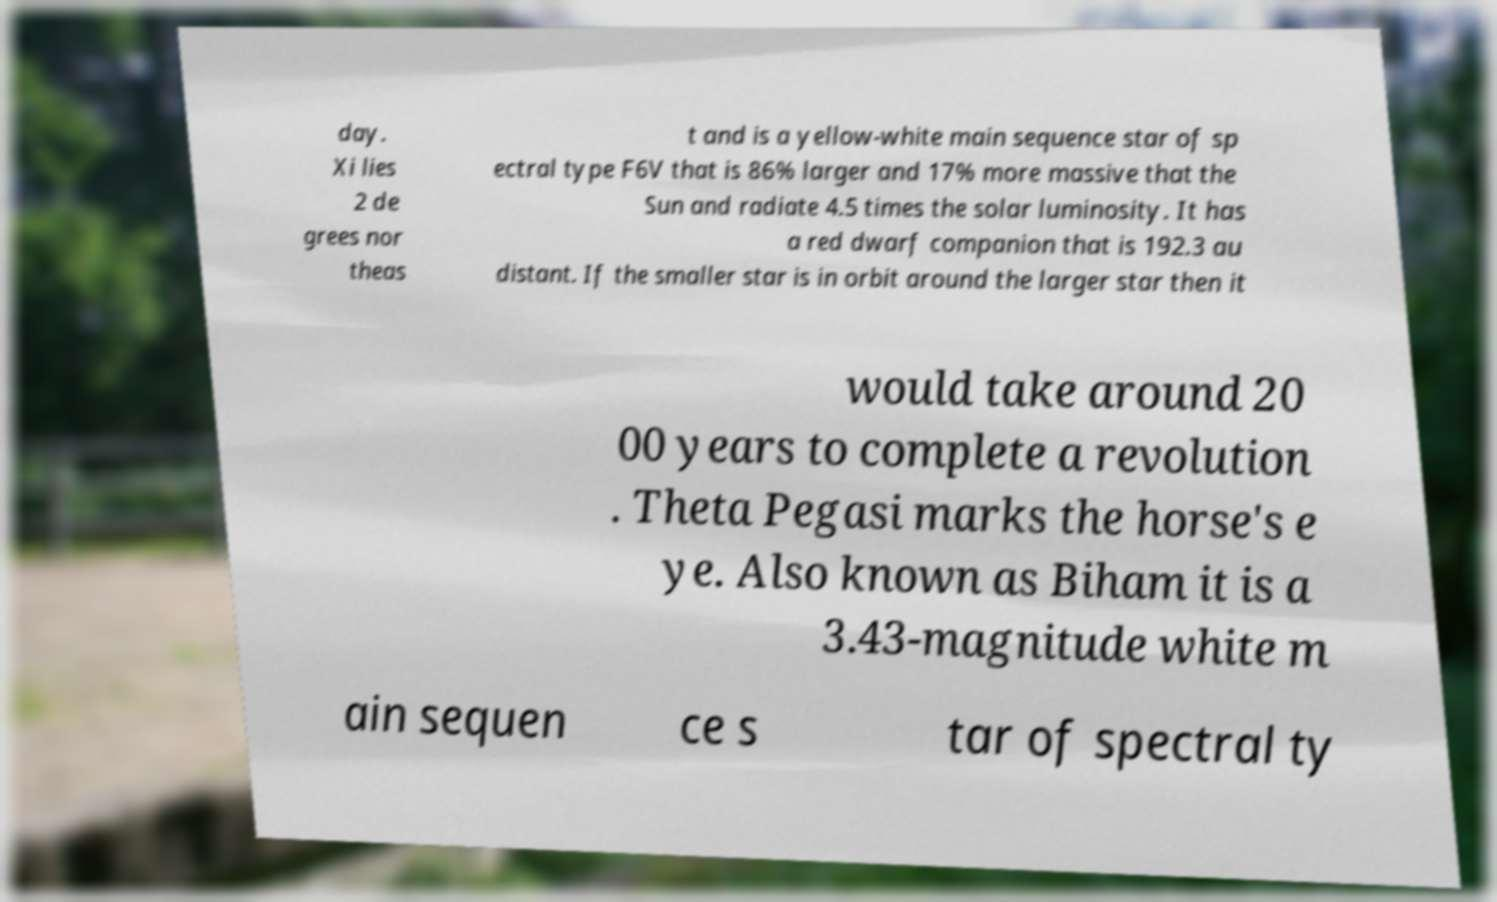Please identify and transcribe the text found in this image. day. Xi lies 2 de grees nor theas t and is a yellow-white main sequence star of sp ectral type F6V that is 86% larger and 17% more massive that the Sun and radiate 4.5 times the solar luminosity. It has a red dwarf companion that is 192.3 au distant. If the smaller star is in orbit around the larger star then it would take around 20 00 years to complete a revolution . Theta Pegasi marks the horse's e ye. Also known as Biham it is a 3.43-magnitude white m ain sequen ce s tar of spectral ty 